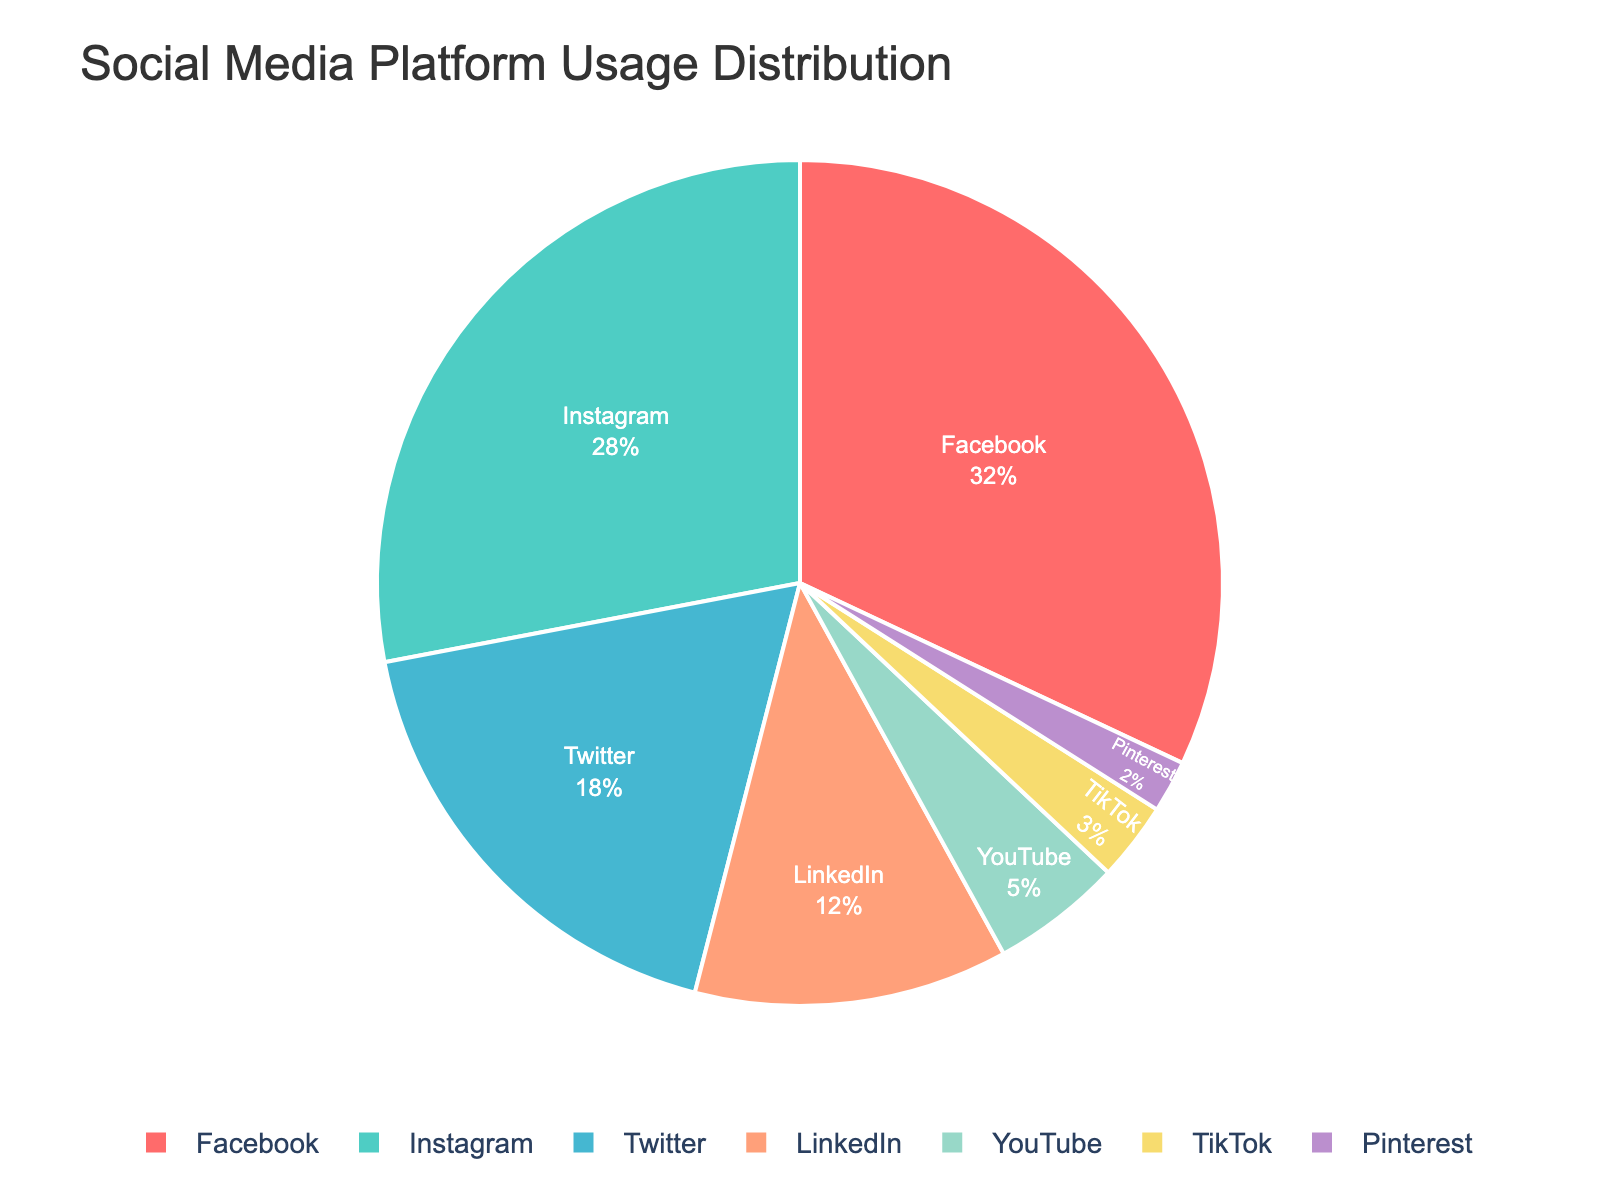Which social media platform has the highest usage percentage? To determine the platform with the highest usage, look at the chart and identify the segment with the largest area. The largest segment represents Facebook with 32%.
Answer: Facebook Which platform has a lower usage percentage, LinkedIn or YouTube? To decide which platform has a lower usage percentage, compare the size of the segments for LinkedIn and YouTube. LinkedIn has 12% while YouTube has 5%, so YouTube has a lower usage percentage.
Answer: YouTube What is the combined percentage usage of Instagram and Twitter? To find the combined usage of Instagram and Twitter, sum their percentages. Instagram has 28% and Twitter has 18%. The sum is 28 + 18 = 46%.
Answer: 46% How much higher is the percentage usage of Facebook compared to TikTok? To find how much higher Facebook's usage is compared to TikTok, subtract TikTok's percentage from Facebook's. Facebook has 32% and TikTok has 3%. The difference is 32 - 3 = 29%.
Answer: 29% Which platform has the third highest usage percentage? Review the chart segments and arrange them in descending order of usage percentages. Facebook is first with 32%, Instagram second with 28%, and Twitter third with 18%.
Answer: Twitter What is the total percentage usage of platforms with more than 10% usage? Identify the platforms with more than 10% usage: Facebook (32%), Instagram (28%), Twitter (18%), and LinkedIn (12%). Sum these values: 32 + 28 + 18 + 12 = 90%.
Answer: 90% Which two platforms have the smallest combined percentage usage? Identify the two smallest segments in the chart, which are TikTok (3%) and Pinterest (2%). Then, sum their percentages: 3 + 2 = 5%.
Answer: 5% Which has a greater usage percentage, the sum of YouTube and TikTok or the usage of Twitter? Sum the percentages for YouTube (5%) and TikTok (3%) to get 8%. Compare this with Twitter's 18%. Since 8% is less than 18%, Twitter has a greater usage percentage.
Answer: Twitter What color represents the Instagram segment in the pie chart? Refer to the visual attributes of the chart; Instagram is represented in light green color.
Answer: Light green By how much does LinkedIn's usage percentage exceed Pinterest's? Subtract Pinterest's percentage from LinkedIn's to find the difference. LinkedIn has 12%, and Pinterest has 2%. The difference is 12 - 2 = 10%.
Answer: 10% 